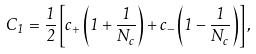<formula> <loc_0><loc_0><loc_500><loc_500>C _ { 1 } = \frac { 1 } { 2 } \left [ c _ { + } \left ( 1 + \frac { 1 } { N _ { c } } \right ) + c _ { - } \left ( 1 - \frac { 1 } { N _ { c } } \right ) \right ] ,</formula> 